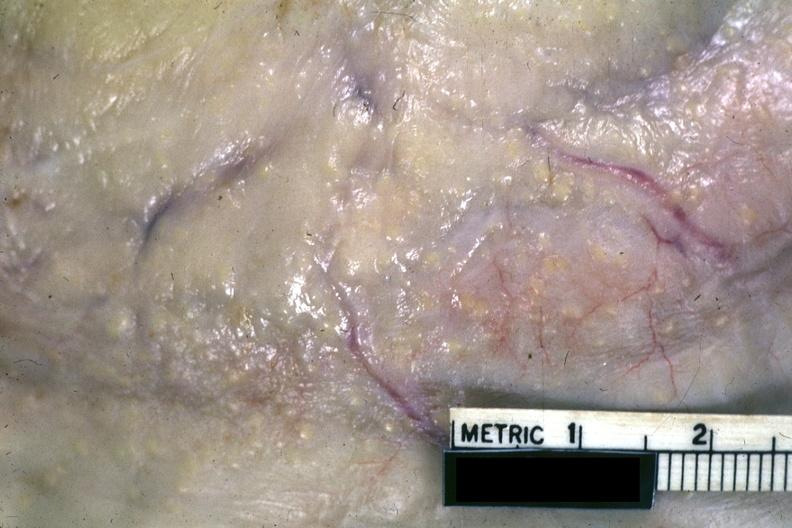does this image show a very close-up view of typical gross lesions?
Answer the question using a single word or phrase. Yes 